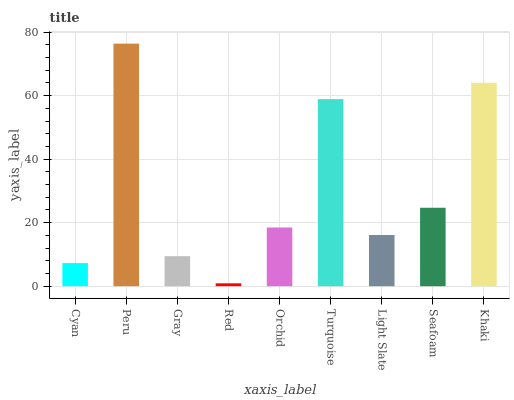Is Red the minimum?
Answer yes or no. Yes. Is Peru the maximum?
Answer yes or no. Yes. Is Gray the minimum?
Answer yes or no. No. Is Gray the maximum?
Answer yes or no. No. Is Peru greater than Gray?
Answer yes or no. Yes. Is Gray less than Peru?
Answer yes or no. Yes. Is Gray greater than Peru?
Answer yes or no. No. Is Peru less than Gray?
Answer yes or no. No. Is Orchid the high median?
Answer yes or no. Yes. Is Orchid the low median?
Answer yes or no. Yes. Is Red the high median?
Answer yes or no. No. Is Seafoam the low median?
Answer yes or no. No. 